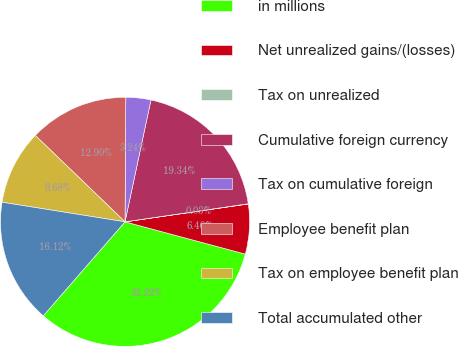Convert chart. <chart><loc_0><loc_0><loc_500><loc_500><pie_chart><fcel>in millions<fcel>Net unrealized gains/(losses)<fcel>Tax on unrealized<fcel>Cumulative foreign currency<fcel>Tax on cumulative foreign<fcel>Employee benefit plan<fcel>Tax on employee benefit plan<fcel>Total accumulated other<nl><fcel>32.22%<fcel>6.46%<fcel>0.03%<fcel>19.34%<fcel>3.24%<fcel>12.9%<fcel>9.68%<fcel>16.12%<nl></chart> 